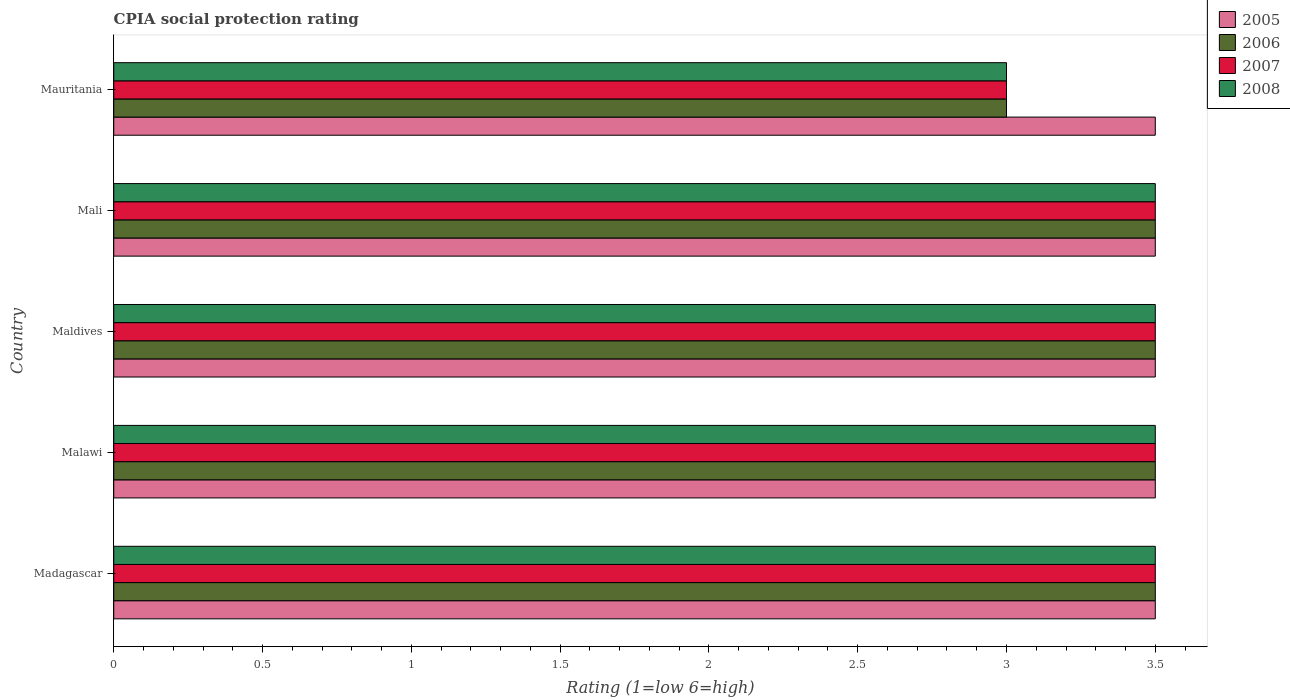How many different coloured bars are there?
Give a very brief answer. 4. Are the number of bars per tick equal to the number of legend labels?
Provide a short and direct response. Yes. How many bars are there on the 2nd tick from the bottom?
Your answer should be compact. 4. What is the label of the 1st group of bars from the top?
Your answer should be compact. Mauritania. What is the CPIA rating in 2007 in Maldives?
Keep it short and to the point. 3.5. Across all countries, what is the maximum CPIA rating in 2005?
Keep it short and to the point. 3.5. Across all countries, what is the minimum CPIA rating in 2008?
Offer a very short reply. 3. In which country was the CPIA rating in 2005 maximum?
Your response must be concise. Madagascar. In which country was the CPIA rating in 2008 minimum?
Your answer should be compact. Mauritania. What is the difference between the CPIA rating in 2008 and CPIA rating in 2007 in Mauritania?
Your response must be concise. 0. In how many countries, is the CPIA rating in 2006 greater than 3.3 ?
Keep it short and to the point. 4. What is the ratio of the CPIA rating in 2006 in Mali to that in Mauritania?
Your answer should be very brief. 1.17. Is the CPIA rating in 2005 in Malawi less than that in Mauritania?
Keep it short and to the point. No. In how many countries, is the CPIA rating in 2008 greater than the average CPIA rating in 2008 taken over all countries?
Provide a succinct answer. 4. Is the sum of the CPIA rating in 2005 in Madagascar and Malawi greater than the maximum CPIA rating in 2008 across all countries?
Your answer should be very brief. Yes. Is it the case that in every country, the sum of the CPIA rating in 2008 and CPIA rating in 2006 is greater than the sum of CPIA rating in 2007 and CPIA rating in 2005?
Ensure brevity in your answer.  No. What does the 3rd bar from the top in Madagascar represents?
Make the answer very short. 2006. What does the 3rd bar from the bottom in Mauritania represents?
Make the answer very short. 2007. Are all the bars in the graph horizontal?
Keep it short and to the point. Yes. Are the values on the major ticks of X-axis written in scientific E-notation?
Ensure brevity in your answer.  No. Does the graph contain any zero values?
Provide a succinct answer. No. Does the graph contain grids?
Give a very brief answer. No. Where does the legend appear in the graph?
Your answer should be very brief. Top right. What is the title of the graph?
Give a very brief answer. CPIA social protection rating. Does "1967" appear as one of the legend labels in the graph?
Ensure brevity in your answer.  No. What is the label or title of the Y-axis?
Your answer should be compact. Country. What is the Rating (1=low 6=high) of 2005 in Madagascar?
Make the answer very short. 3.5. What is the Rating (1=low 6=high) of 2007 in Madagascar?
Your answer should be very brief. 3.5. What is the Rating (1=low 6=high) in 2008 in Madagascar?
Make the answer very short. 3.5. What is the Rating (1=low 6=high) of 2005 in Malawi?
Your answer should be compact. 3.5. What is the Rating (1=low 6=high) in 2006 in Malawi?
Make the answer very short. 3.5. What is the Rating (1=low 6=high) in 2007 in Malawi?
Offer a terse response. 3.5. What is the Rating (1=low 6=high) of 2008 in Malawi?
Make the answer very short. 3.5. What is the Rating (1=low 6=high) of 2005 in Maldives?
Your answer should be compact. 3.5. What is the Rating (1=low 6=high) in 2007 in Maldives?
Make the answer very short. 3.5. What is the Rating (1=low 6=high) in 2008 in Maldives?
Ensure brevity in your answer.  3.5. What is the Rating (1=low 6=high) of 2005 in Mali?
Ensure brevity in your answer.  3.5. What is the Rating (1=low 6=high) of 2007 in Mali?
Offer a terse response. 3.5. What is the Rating (1=low 6=high) in 2008 in Mali?
Your response must be concise. 3.5. What is the Rating (1=low 6=high) of 2007 in Mauritania?
Offer a very short reply. 3. What is the Rating (1=low 6=high) of 2008 in Mauritania?
Provide a succinct answer. 3. Across all countries, what is the maximum Rating (1=low 6=high) in 2005?
Keep it short and to the point. 3.5. Across all countries, what is the maximum Rating (1=low 6=high) in 2006?
Your response must be concise. 3.5. Across all countries, what is the maximum Rating (1=low 6=high) of 2008?
Ensure brevity in your answer.  3.5. Across all countries, what is the minimum Rating (1=low 6=high) of 2005?
Provide a succinct answer. 3.5. Across all countries, what is the minimum Rating (1=low 6=high) in 2006?
Ensure brevity in your answer.  3. What is the total Rating (1=low 6=high) of 2005 in the graph?
Provide a succinct answer. 17.5. What is the total Rating (1=low 6=high) of 2006 in the graph?
Offer a very short reply. 17. What is the total Rating (1=low 6=high) of 2007 in the graph?
Offer a terse response. 17. What is the total Rating (1=low 6=high) of 2008 in the graph?
Offer a terse response. 17. What is the difference between the Rating (1=low 6=high) of 2005 in Madagascar and that in Malawi?
Your response must be concise. 0. What is the difference between the Rating (1=low 6=high) in 2008 in Madagascar and that in Malawi?
Your answer should be very brief. 0. What is the difference between the Rating (1=low 6=high) in 2006 in Madagascar and that in Maldives?
Give a very brief answer. 0. What is the difference between the Rating (1=low 6=high) of 2008 in Madagascar and that in Maldives?
Offer a terse response. 0. What is the difference between the Rating (1=low 6=high) in 2006 in Madagascar and that in Mali?
Your response must be concise. 0. What is the difference between the Rating (1=low 6=high) of 2008 in Madagascar and that in Mauritania?
Offer a terse response. 0.5. What is the difference between the Rating (1=low 6=high) in 2005 in Malawi and that in Mali?
Your answer should be compact. 0. What is the difference between the Rating (1=low 6=high) in 2006 in Malawi and that in Mali?
Make the answer very short. 0. What is the difference between the Rating (1=low 6=high) in 2007 in Malawi and that in Mali?
Your answer should be compact. 0. What is the difference between the Rating (1=low 6=high) in 2007 in Malawi and that in Mauritania?
Provide a short and direct response. 0.5. What is the difference between the Rating (1=low 6=high) in 2006 in Maldives and that in Mali?
Make the answer very short. 0. What is the difference between the Rating (1=low 6=high) of 2008 in Maldives and that in Mali?
Provide a short and direct response. 0. What is the difference between the Rating (1=low 6=high) of 2005 in Maldives and that in Mauritania?
Keep it short and to the point. 0. What is the difference between the Rating (1=low 6=high) of 2006 in Maldives and that in Mauritania?
Provide a succinct answer. 0.5. What is the difference between the Rating (1=low 6=high) of 2006 in Mali and that in Mauritania?
Offer a very short reply. 0.5. What is the difference between the Rating (1=low 6=high) of 2007 in Mali and that in Mauritania?
Ensure brevity in your answer.  0.5. What is the difference between the Rating (1=low 6=high) in 2008 in Mali and that in Mauritania?
Your response must be concise. 0.5. What is the difference between the Rating (1=low 6=high) of 2005 in Madagascar and the Rating (1=low 6=high) of 2008 in Malawi?
Make the answer very short. 0. What is the difference between the Rating (1=low 6=high) in 2007 in Madagascar and the Rating (1=low 6=high) in 2008 in Malawi?
Offer a very short reply. 0. What is the difference between the Rating (1=low 6=high) in 2005 in Madagascar and the Rating (1=low 6=high) in 2008 in Maldives?
Make the answer very short. 0. What is the difference between the Rating (1=low 6=high) of 2006 in Madagascar and the Rating (1=low 6=high) of 2007 in Maldives?
Provide a short and direct response. 0. What is the difference between the Rating (1=low 6=high) in 2006 in Madagascar and the Rating (1=low 6=high) in 2008 in Maldives?
Provide a succinct answer. 0. What is the difference between the Rating (1=low 6=high) in 2006 in Madagascar and the Rating (1=low 6=high) in 2008 in Mali?
Make the answer very short. 0. What is the difference between the Rating (1=low 6=high) of 2007 in Madagascar and the Rating (1=low 6=high) of 2008 in Mali?
Offer a very short reply. 0. What is the difference between the Rating (1=low 6=high) in 2005 in Madagascar and the Rating (1=low 6=high) in 2006 in Mauritania?
Provide a succinct answer. 0.5. What is the difference between the Rating (1=low 6=high) of 2005 in Madagascar and the Rating (1=low 6=high) of 2007 in Mauritania?
Offer a very short reply. 0.5. What is the difference between the Rating (1=low 6=high) in 2005 in Madagascar and the Rating (1=low 6=high) in 2008 in Mauritania?
Offer a terse response. 0.5. What is the difference between the Rating (1=low 6=high) in 2006 in Madagascar and the Rating (1=low 6=high) in 2008 in Mauritania?
Your answer should be compact. 0.5. What is the difference between the Rating (1=low 6=high) in 2005 in Malawi and the Rating (1=low 6=high) in 2006 in Maldives?
Your answer should be compact. 0. What is the difference between the Rating (1=low 6=high) in 2005 in Malawi and the Rating (1=low 6=high) in 2007 in Maldives?
Give a very brief answer. 0. What is the difference between the Rating (1=low 6=high) of 2005 in Malawi and the Rating (1=low 6=high) of 2006 in Mali?
Your answer should be compact. 0. What is the difference between the Rating (1=low 6=high) of 2006 in Malawi and the Rating (1=low 6=high) of 2007 in Mali?
Make the answer very short. 0. What is the difference between the Rating (1=low 6=high) in 2006 in Malawi and the Rating (1=low 6=high) in 2008 in Mali?
Offer a terse response. 0. What is the difference between the Rating (1=low 6=high) in 2007 in Malawi and the Rating (1=low 6=high) in 2008 in Mali?
Your response must be concise. 0. What is the difference between the Rating (1=low 6=high) of 2005 in Malawi and the Rating (1=low 6=high) of 2008 in Mauritania?
Your answer should be compact. 0.5. What is the difference between the Rating (1=low 6=high) of 2006 in Malawi and the Rating (1=low 6=high) of 2008 in Mauritania?
Provide a short and direct response. 0.5. What is the difference between the Rating (1=low 6=high) of 2007 in Malawi and the Rating (1=low 6=high) of 2008 in Mauritania?
Offer a very short reply. 0.5. What is the difference between the Rating (1=low 6=high) of 2006 in Maldives and the Rating (1=low 6=high) of 2008 in Mali?
Your response must be concise. 0. What is the difference between the Rating (1=low 6=high) of 2006 in Maldives and the Rating (1=low 6=high) of 2008 in Mauritania?
Give a very brief answer. 0.5. What is the difference between the Rating (1=low 6=high) in 2005 in Mali and the Rating (1=low 6=high) in 2006 in Mauritania?
Your answer should be compact. 0.5. What is the difference between the Rating (1=low 6=high) of 2006 in Mali and the Rating (1=low 6=high) of 2007 in Mauritania?
Provide a short and direct response. 0.5. What is the difference between the Rating (1=low 6=high) of 2006 in Mali and the Rating (1=low 6=high) of 2008 in Mauritania?
Keep it short and to the point. 0.5. What is the average Rating (1=low 6=high) of 2008 per country?
Provide a succinct answer. 3.4. What is the difference between the Rating (1=low 6=high) of 2005 and Rating (1=low 6=high) of 2006 in Madagascar?
Provide a succinct answer. 0. What is the difference between the Rating (1=low 6=high) in 2005 and Rating (1=low 6=high) in 2007 in Madagascar?
Offer a terse response. 0. What is the difference between the Rating (1=low 6=high) in 2006 and Rating (1=low 6=high) in 2008 in Madagascar?
Your answer should be compact. 0. What is the difference between the Rating (1=low 6=high) of 2007 and Rating (1=low 6=high) of 2008 in Madagascar?
Your answer should be very brief. 0. What is the difference between the Rating (1=low 6=high) in 2005 and Rating (1=low 6=high) in 2007 in Malawi?
Offer a terse response. 0. What is the difference between the Rating (1=low 6=high) of 2005 and Rating (1=low 6=high) of 2008 in Malawi?
Offer a very short reply. 0. What is the difference between the Rating (1=low 6=high) of 2007 and Rating (1=low 6=high) of 2008 in Malawi?
Provide a succinct answer. 0. What is the difference between the Rating (1=low 6=high) of 2005 and Rating (1=low 6=high) of 2007 in Maldives?
Your answer should be very brief. 0. What is the difference between the Rating (1=low 6=high) in 2005 and Rating (1=low 6=high) in 2008 in Maldives?
Keep it short and to the point. 0. What is the difference between the Rating (1=low 6=high) in 2006 and Rating (1=low 6=high) in 2007 in Maldives?
Keep it short and to the point. 0. What is the difference between the Rating (1=low 6=high) of 2007 and Rating (1=low 6=high) of 2008 in Maldives?
Offer a terse response. 0. What is the difference between the Rating (1=low 6=high) of 2005 and Rating (1=low 6=high) of 2007 in Mali?
Your answer should be very brief. 0. What is the difference between the Rating (1=low 6=high) of 2005 and Rating (1=low 6=high) of 2006 in Mauritania?
Provide a succinct answer. 0.5. What is the difference between the Rating (1=low 6=high) in 2005 and Rating (1=low 6=high) in 2007 in Mauritania?
Provide a succinct answer. 0.5. What is the difference between the Rating (1=low 6=high) of 2005 and Rating (1=low 6=high) of 2008 in Mauritania?
Provide a succinct answer. 0.5. What is the difference between the Rating (1=low 6=high) of 2006 and Rating (1=low 6=high) of 2007 in Mauritania?
Offer a terse response. 0. What is the ratio of the Rating (1=low 6=high) of 2006 in Madagascar to that in Malawi?
Give a very brief answer. 1. What is the ratio of the Rating (1=low 6=high) of 2005 in Madagascar to that in Maldives?
Ensure brevity in your answer.  1. What is the ratio of the Rating (1=low 6=high) of 2007 in Madagascar to that in Maldives?
Your response must be concise. 1. What is the ratio of the Rating (1=low 6=high) in 2008 in Madagascar to that in Maldives?
Keep it short and to the point. 1. What is the ratio of the Rating (1=low 6=high) of 2008 in Madagascar to that in Mali?
Your answer should be compact. 1. What is the ratio of the Rating (1=low 6=high) in 2005 in Madagascar to that in Mauritania?
Ensure brevity in your answer.  1. What is the ratio of the Rating (1=low 6=high) in 2007 in Madagascar to that in Mauritania?
Ensure brevity in your answer.  1.17. What is the ratio of the Rating (1=low 6=high) of 2008 in Madagascar to that in Mauritania?
Offer a very short reply. 1.17. What is the ratio of the Rating (1=low 6=high) in 2005 in Malawi to that in Maldives?
Offer a very short reply. 1. What is the ratio of the Rating (1=low 6=high) of 2007 in Malawi to that in Maldives?
Make the answer very short. 1. What is the ratio of the Rating (1=low 6=high) of 2006 in Malawi to that in Mali?
Make the answer very short. 1. What is the ratio of the Rating (1=low 6=high) of 2008 in Malawi to that in Mali?
Your response must be concise. 1. What is the ratio of the Rating (1=low 6=high) of 2008 in Malawi to that in Mauritania?
Offer a very short reply. 1.17. What is the ratio of the Rating (1=low 6=high) of 2008 in Maldives to that in Mali?
Make the answer very short. 1. What is the ratio of the Rating (1=low 6=high) of 2005 in Maldives to that in Mauritania?
Your response must be concise. 1. What is the ratio of the Rating (1=low 6=high) in 2006 in Maldives to that in Mauritania?
Your answer should be very brief. 1.17. What is the ratio of the Rating (1=low 6=high) of 2007 in Maldives to that in Mauritania?
Your response must be concise. 1.17. What is the ratio of the Rating (1=low 6=high) of 2005 in Mali to that in Mauritania?
Provide a short and direct response. 1. What is the ratio of the Rating (1=low 6=high) of 2006 in Mali to that in Mauritania?
Keep it short and to the point. 1.17. What is the difference between the highest and the second highest Rating (1=low 6=high) in 2005?
Your answer should be compact. 0. What is the difference between the highest and the second highest Rating (1=low 6=high) in 2006?
Give a very brief answer. 0. What is the difference between the highest and the second highest Rating (1=low 6=high) in 2008?
Provide a succinct answer. 0. What is the difference between the highest and the lowest Rating (1=low 6=high) of 2006?
Provide a succinct answer. 0.5. What is the difference between the highest and the lowest Rating (1=low 6=high) in 2008?
Your response must be concise. 0.5. 